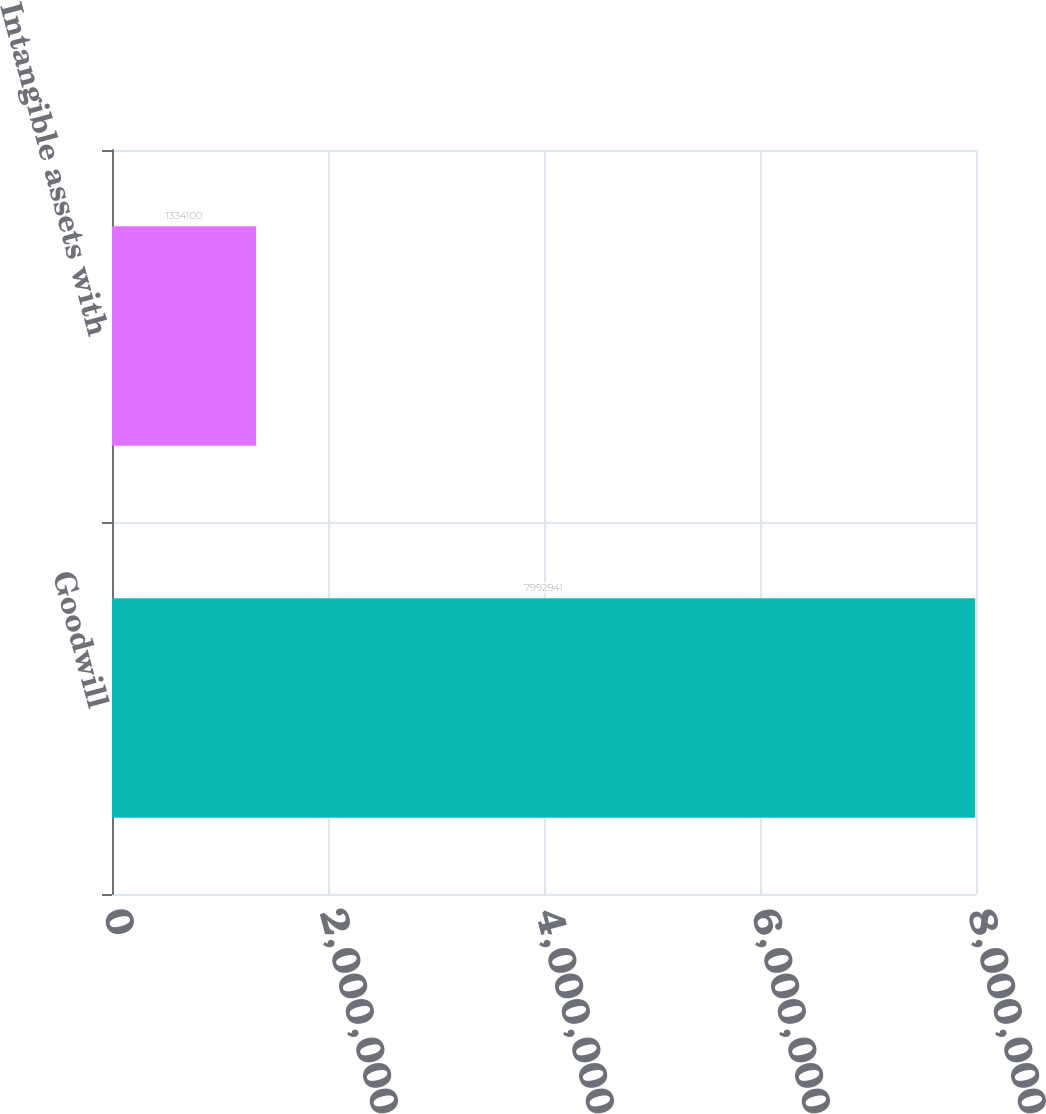Convert chart to OTSL. <chart><loc_0><loc_0><loc_500><loc_500><bar_chart><fcel>Goodwill<fcel>Intangible assets with<nl><fcel>7.99294e+06<fcel>1.3341e+06<nl></chart> 